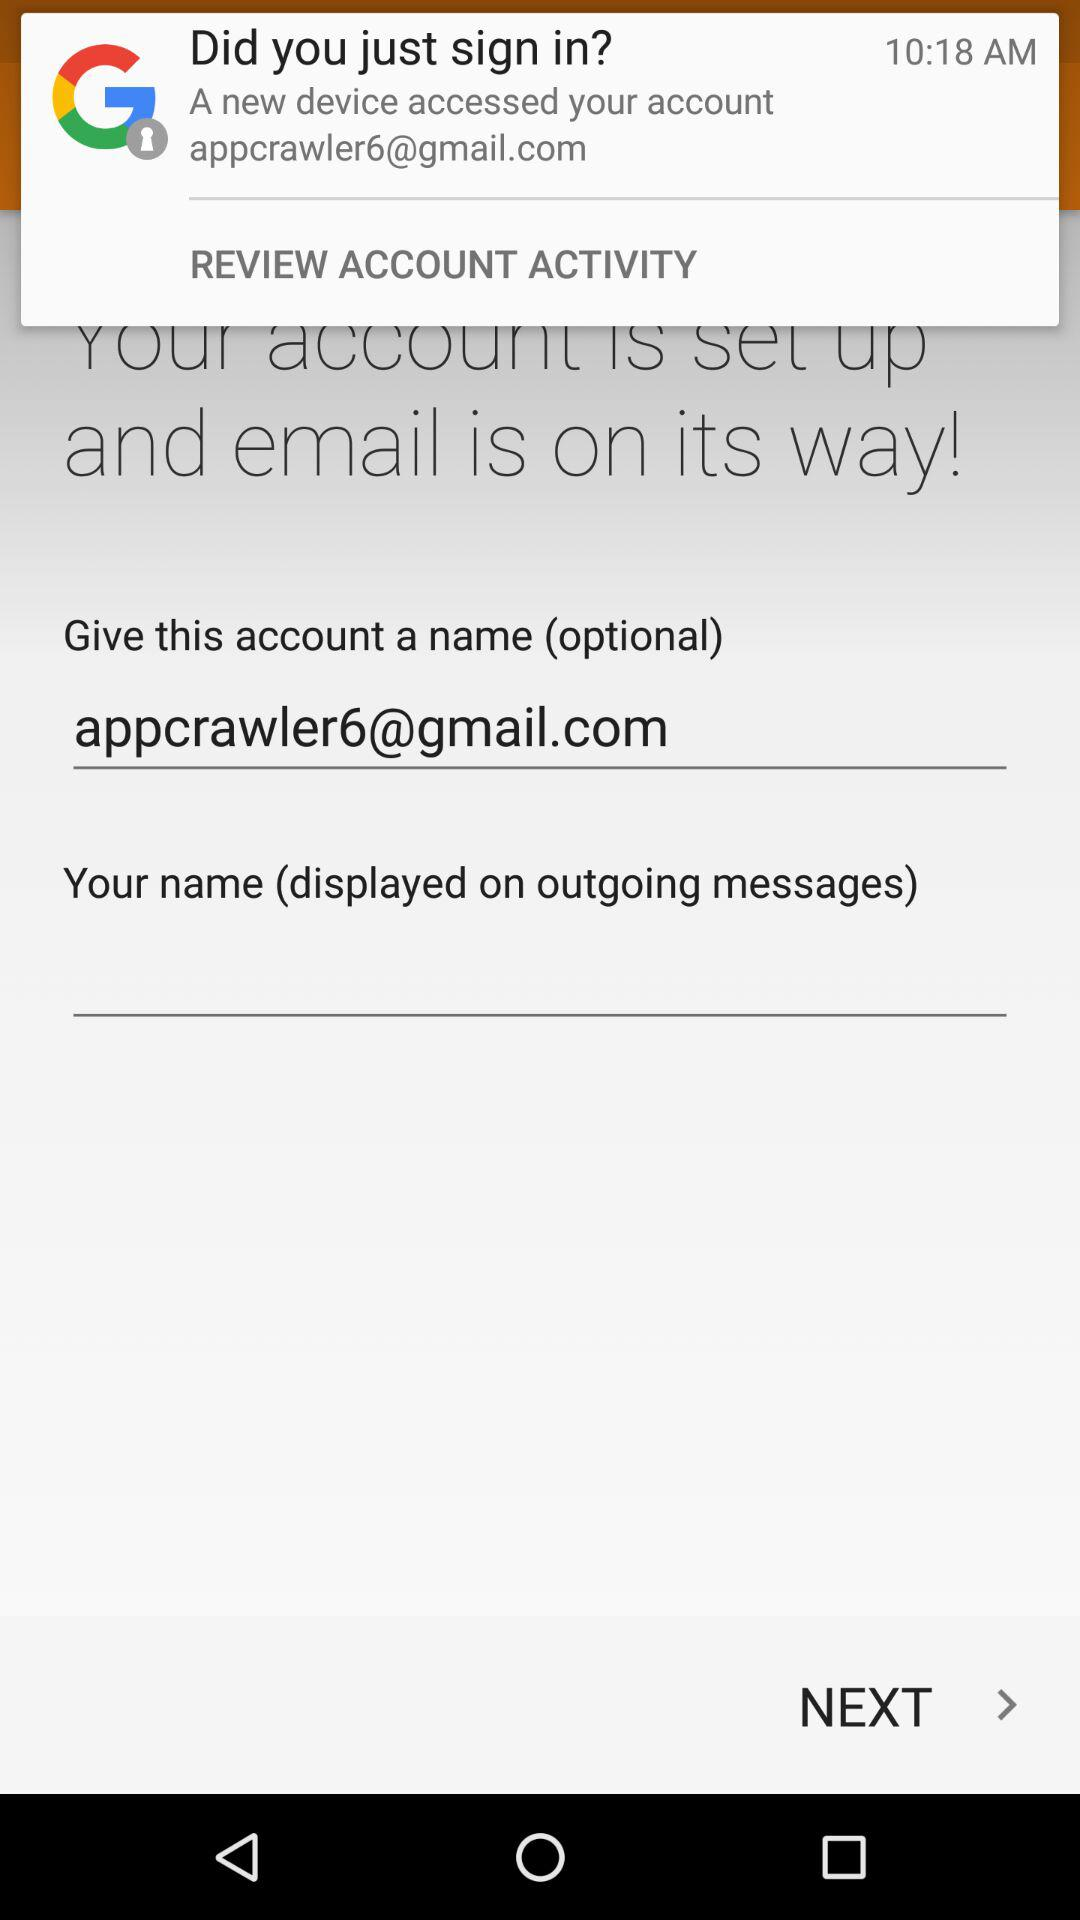At what time did the user sign in? The user signed in at 10:18 AM. 